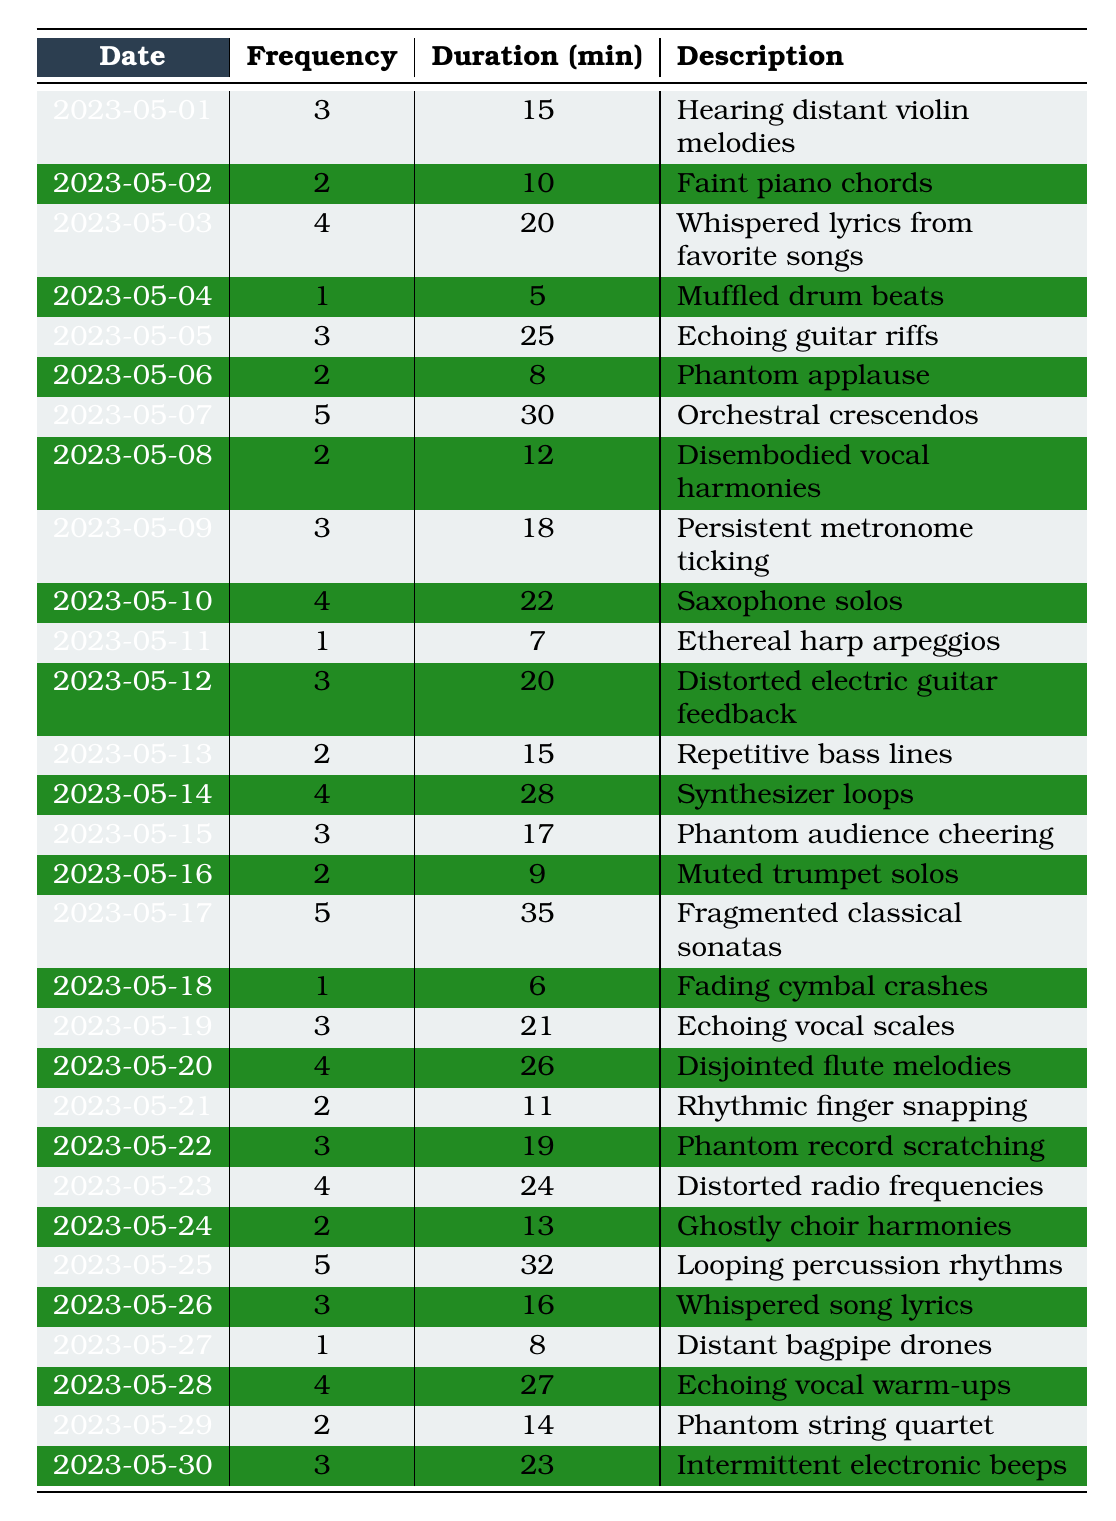What was the highest frequency of auditory hallucinations recorded? By examining the frequency column, the highest value is in the row for 2023-05-17 with a frequency of 5.
Answer: 5 What is the total duration of auditory hallucinations over the 30 days? To find the total duration, I will sum the duration minutes for all entries: 15 + 10 + 20 + 5 + 25 + 8 + 30 + 12 + 18 + 22 + 7 + 20 + 15 + 28 + 17 + 9 + 35 + 6 + 21 + 26 + 11 + 19 + 24 + 13 + 32 + 16 + 8 + 27 + 14 + 23 =  535 minutes.
Answer: 535 minutes On how many days did the frequency of hallucinations exceed 4? Looking through the frequency column, there are 7 days where the frequency is greater than 4 (2023-05-07, 2023-05-14, 2023-05-17, 2023-05-25).
Answer: 4 days What is the average duration of auditory hallucinations across all days? To calculate the average duration, sum all durations (535) and divide by the number of days (30): 535/30 = 17.83, approximately 18 minutes.
Answer: 18 minutes Were there more auditory hallucinations on weekends compared to weekdays? I will evaluate the entries by checking if the dates fall on a Saturday (6) or Sunday (7). There are 8 occurrences over weekends (2-3 May) and the rest are on weekdays, leading to weekdays having more occurrences.
Answer: No What were the most common descriptions of the auditory hallucinations? Scanning through the description column, several terms repeat, like "phantom" and "echoing," showing common themes in what was experienced.
Answer: Common themes include "phantom" and "echoing." What is the difference in total frequency between the days with the lowest and highest hallucination counts? The lowest frequency is 1 and the highest is 5, so the difference is 5 - 1 = 4.
Answer: 4 How often did auditory hallucinations occur on May 10th compared to May 18th? On May 10th, the frequency is 4, while on May 18th, it is 1, resulting in a difference of 3 occurrences.
Answer: 3 times more frequent on May 10th What is the longest duration of auditory hallucination experienced on a single day? By reviewing the duration column, the longest duration is 35 minutes on 2023-05-17.
Answer: 35 minutes Was the average frequency of hallucinations on even days higher than on odd days? Calculate both averages: even days total frequency = 51 over 15 days = 3.4; odd days total frequency = 54 over 15 days = 3.6. The average for odd days is higher.
Answer: Yes, odd days had a higher average frequency 